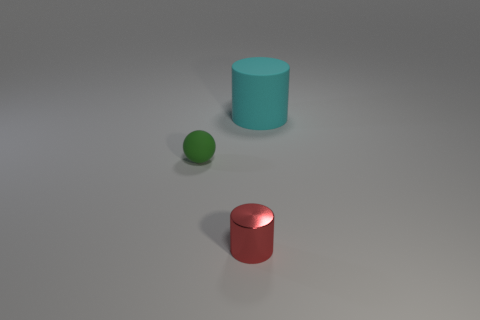Add 3 big cyan matte objects. How many objects exist? 6 Subtract all balls. How many objects are left? 2 Subtract 0 red blocks. How many objects are left? 3 Subtract all small gray metal cylinders. Subtract all small metal objects. How many objects are left? 2 Add 1 large things. How many large things are left? 2 Add 2 cyan cylinders. How many cyan cylinders exist? 3 